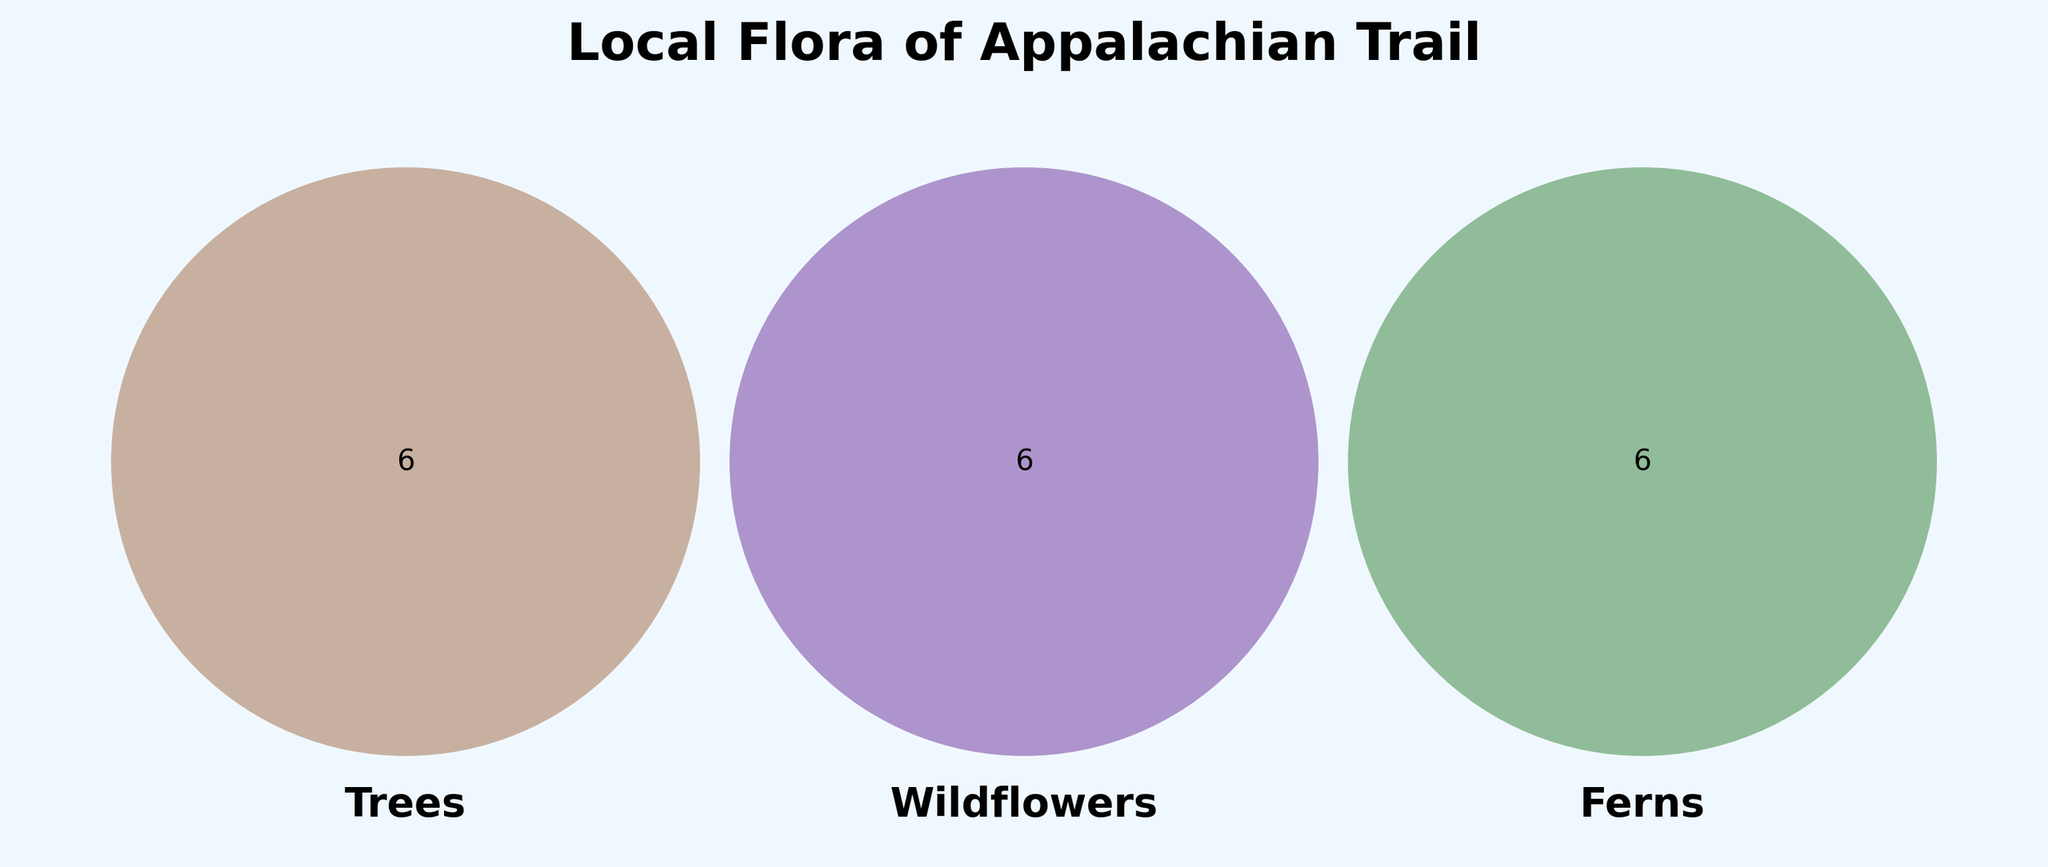How many types of trees are shown in the Venn diagram? Count the number of unique tree names listed.
Answer: 6 What's the color representing 'Wildflowers' in the Venn Diagram? Identify the specific color used in the diagram.
Answer: Purple Which category has 'Dogwood' listed under it? Check the subsets and locate 'Dogwood' in the appropriate category.
Answer: Trees Are there any plants belonging to all three categories: trees, wildflowers, and ferns? Find the intersection of all three sets in the Venn diagram.
Answer: No How many categories have 'Birch' in them? Identify the number of categories in which 'Birch' appears.
Answer: 1 Which category shares the most number of plants with 'Wildflowers'? Compare the intersection sizes between 'Wildflowers' and the other two categories.
Answer: Trees What are the names of trees found near the Appalachian Trail? List out all the plant names under the category 'Trees'.
Answer: Oak, Maple, Birch, Hickory, Dogwood, Pine Do any ferns share their name with any wildflowers based on the Venn diagram? Examine the intersections between the 'Ferns' and 'Wildflowers' sets.
Answer: No Which category has the largest diversity in plant types? Compare the number of unique items in each category.
Answer: Wildflowers 